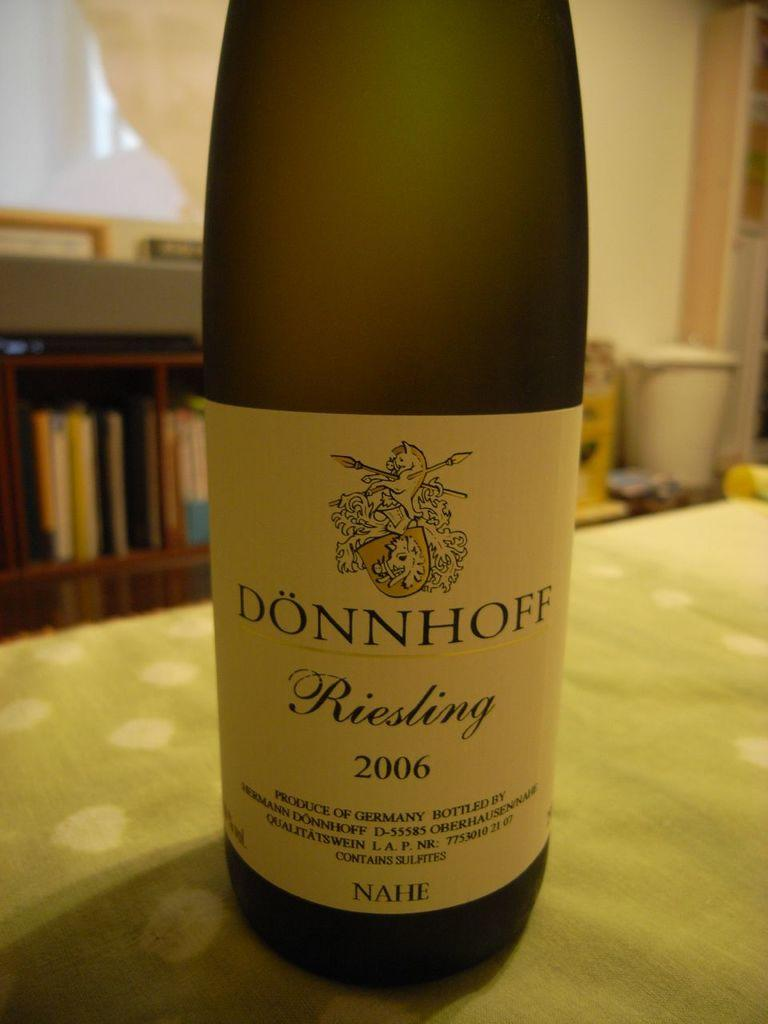<image>
Render a clear and concise summary of the photo. A bottle of Donnhoff Riseling on a table. 